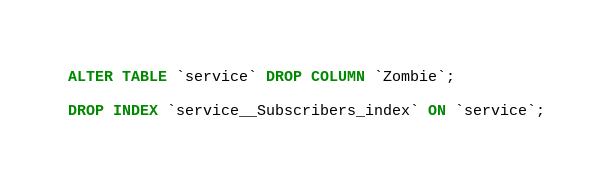Convert code to text. <code><loc_0><loc_0><loc_500><loc_500><_SQL_>ALTER TABLE `service` DROP COLUMN `Zombie`;

DROP INDEX `service__Subscribers_index` ON `service`;

</code> 